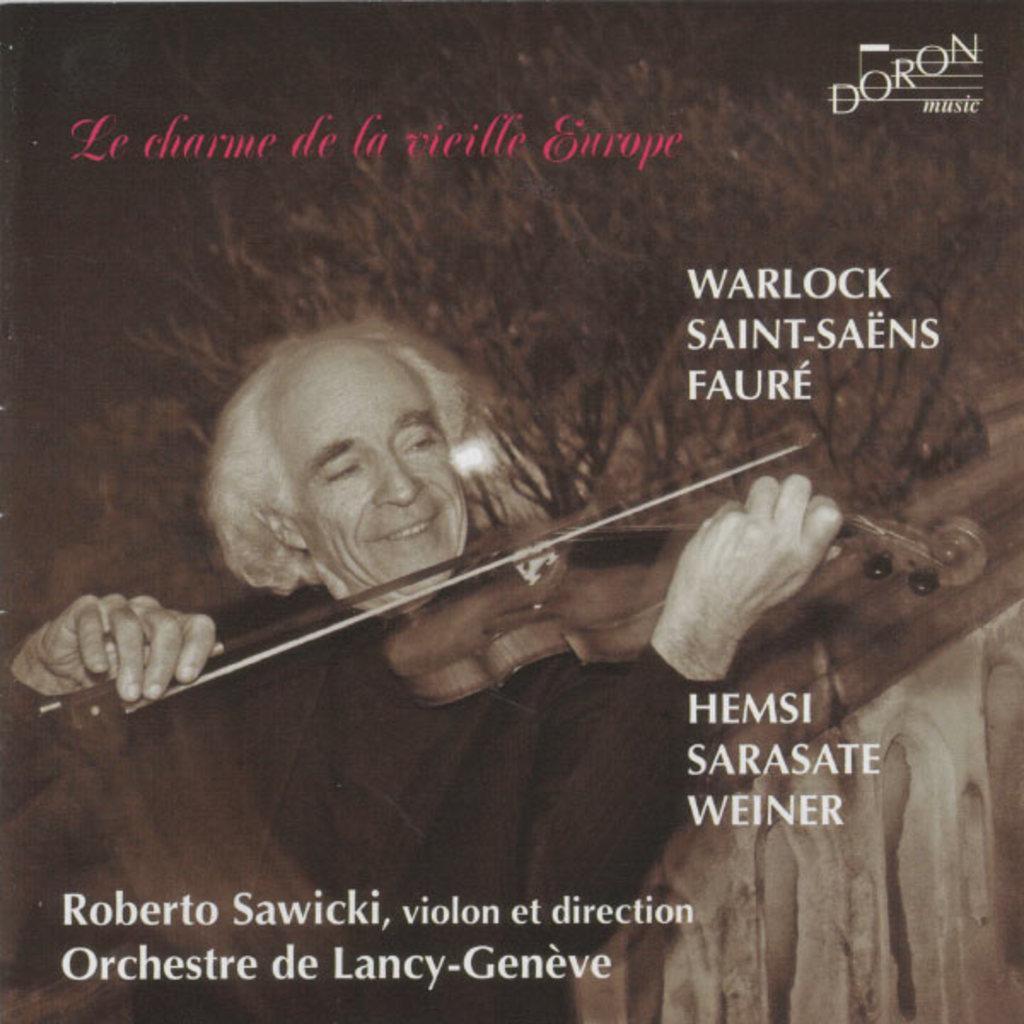Can you describe this image briefly? In this picture we can see a cover page, in the cover page we can find a man, he is playing violin and we can see some text. 